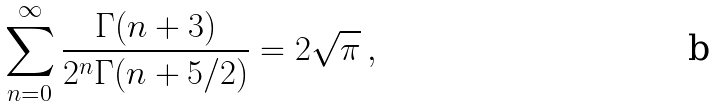<formula> <loc_0><loc_0><loc_500><loc_500>\sum _ { n = 0 } ^ { \infty } \frac { \Gamma ( n + 3 ) } { 2 ^ { n } \Gamma ( n + 5 / 2 ) } = 2 \sqrt { \pi } \, ,</formula> 